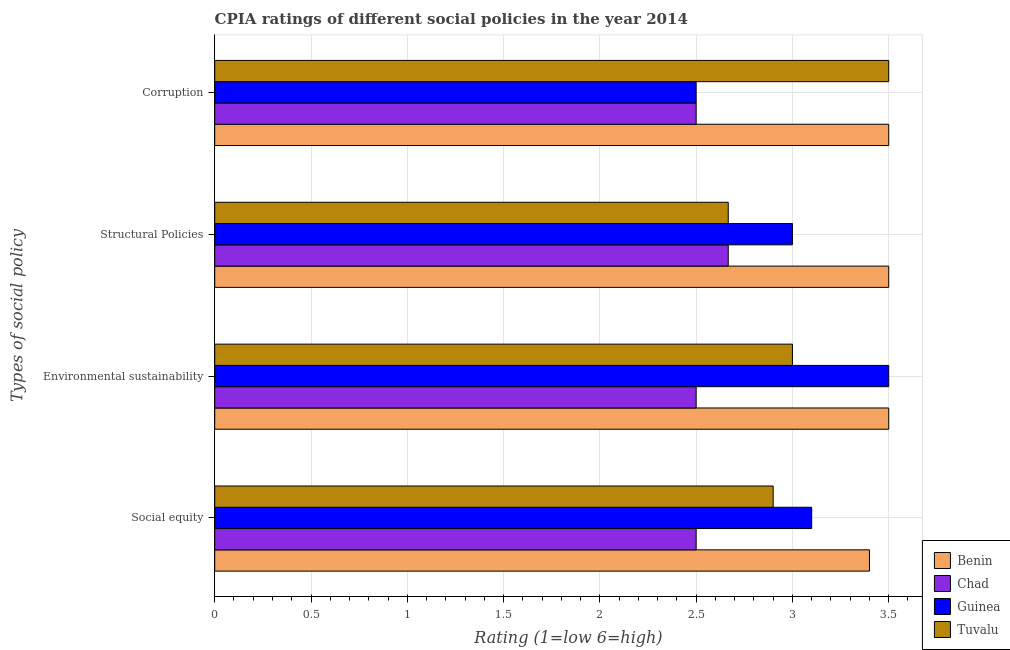How many groups of bars are there?
Give a very brief answer. 4. How many bars are there on the 1st tick from the bottom?
Offer a terse response. 4. What is the label of the 1st group of bars from the top?
Keep it short and to the point. Corruption. What is the cpia rating of structural policies in Tuvalu?
Your response must be concise. 2.67. Across all countries, what is the maximum cpia rating of social equity?
Offer a very short reply. 3.4. Across all countries, what is the minimum cpia rating of structural policies?
Make the answer very short. 2.67. In which country was the cpia rating of social equity maximum?
Your response must be concise. Benin. In which country was the cpia rating of environmental sustainability minimum?
Ensure brevity in your answer.  Chad. What is the total cpia rating of corruption in the graph?
Your answer should be very brief. 12. What is the difference between the cpia rating of structural policies in Tuvalu and that in Guinea?
Your answer should be very brief. -0.33. What is the difference between the cpia rating of corruption in Guinea and the cpia rating of social equity in Benin?
Provide a short and direct response. -0.9. What is the average cpia rating of environmental sustainability per country?
Your response must be concise. 3.12. What is the difference between the cpia rating of social equity and cpia rating of structural policies in Tuvalu?
Provide a short and direct response. 0.23. In how many countries, is the cpia rating of environmental sustainability greater than 2.4 ?
Give a very brief answer. 4. What is the ratio of the cpia rating of social equity in Tuvalu to that in Chad?
Your answer should be compact. 1.16. What is the difference between the highest and the lowest cpia rating of corruption?
Offer a very short reply. 1. Is the sum of the cpia rating of social equity in Benin and Guinea greater than the maximum cpia rating of structural policies across all countries?
Offer a very short reply. Yes. Is it the case that in every country, the sum of the cpia rating of corruption and cpia rating of environmental sustainability is greater than the sum of cpia rating of social equity and cpia rating of structural policies?
Offer a very short reply. No. What does the 4th bar from the top in Structural Policies represents?
Your answer should be very brief. Benin. What does the 3rd bar from the bottom in Environmental sustainability represents?
Give a very brief answer. Guinea. How many bars are there?
Offer a very short reply. 16. Are all the bars in the graph horizontal?
Give a very brief answer. Yes. How many countries are there in the graph?
Offer a very short reply. 4. What is the difference between two consecutive major ticks on the X-axis?
Your answer should be very brief. 0.5. Does the graph contain any zero values?
Ensure brevity in your answer.  No. What is the title of the graph?
Ensure brevity in your answer.  CPIA ratings of different social policies in the year 2014. Does "Afghanistan" appear as one of the legend labels in the graph?
Your response must be concise. No. What is the label or title of the Y-axis?
Provide a succinct answer. Types of social policy. What is the Rating (1=low 6=high) in Chad in Social equity?
Offer a very short reply. 2.5. What is the Rating (1=low 6=high) in Chad in Environmental sustainability?
Ensure brevity in your answer.  2.5. What is the Rating (1=low 6=high) in Benin in Structural Policies?
Your answer should be compact. 3.5. What is the Rating (1=low 6=high) of Chad in Structural Policies?
Make the answer very short. 2.67. What is the Rating (1=low 6=high) in Guinea in Structural Policies?
Offer a very short reply. 3. What is the Rating (1=low 6=high) of Tuvalu in Structural Policies?
Your answer should be compact. 2.67. What is the Rating (1=low 6=high) in Benin in Corruption?
Provide a short and direct response. 3.5. What is the Rating (1=low 6=high) in Chad in Corruption?
Offer a very short reply. 2.5. What is the Rating (1=low 6=high) of Tuvalu in Corruption?
Your response must be concise. 3.5. Across all Types of social policy, what is the maximum Rating (1=low 6=high) of Benin?
Make the answer very short. 3.5. Across all Types of social policy, what is the maximum Rating (1=low 6=high) in Chad?
Give a very brief answer. 2.67. Across all Types of social policy, what is the maximum Rating (1=low 6=high) in Tuvalu?
Offer a very short reply. 3.5. Across all Types of social policy, what is the minimum Rating (1=low 6=high) of Benin?
Offer a very short reply. 3.4. Across all Types of social policy, what is the minimum Rating (1=low 6=high) in Chad?
Ensure brevity in your answer.  2.5. Across all Types of social policy, what is the minimum Rating (1=low 6=high) in Guinea?
Offer a very short reply. 2.5. Across all Types of social policy, what is the minimum Rating (1=low 6=high) in Tuvalu?
Offer a very short reply. 2.67. What is the total Rating (1=low 6=high) in Chad in the graph?
Your answer should be very brief. 10.17. What is the total Rating (1=low 6=high) in Tuvalu in the graph?
Offer a very short reply. 12.07. What is the difference between the Rating (1=low 6=high) in Benin in Social equity and that in Environmental sustainability?
Your response must be concise. -0.1. What is the difference between the Rating (1=low 6=high) in Chad in Social equity and that in Environmental sustainability?
Give a very brief answer. 0. What is the difference between the Rating (1=low 6=high) of Guinea in Social equity and that in Environmental sustainability?
Provide a short and direct response. -0.4. What is the difference between the Rating (1=low 6=high) in Tuvalu in Social equity and that in Environmental sustainability?
Provide a short and direct response. -0.1. What is the difference between the Rating (1=low 6=high) of Guinea in Social equity and that in Structural Policies?
Offer a very short reply. 0.1. What is the difference between the Rating (1=low 6=high) of Tuvalu in Social equity and that in Structural Policies?
Provide a succinct answer. 0.23. What is the difference between the Rating (1=low 6=high) of Tuvalu in Social equity and that in Corruption?
Make the answer very short. -0.6. What is the difference between the Rating (1=low 6=high) in Tuvalu in Environmental sustainability and that in Structural Policies?
Keep it short and to the point. 0.33. What is the difference between the Rating (1=low 6=high) of Tuvalu in Environmental sustainability and that in Corruption?
Provide a short and direct response. -0.5. What is the difference between the Rating (1=low 6=high) in Benin in Structural Policies and that in Corruption?
Your answer should be compact. 0. What is the difference between the Rating (1=low 6=high) of Guinea in Structural Policies and that in Corruption?
Make the answer very short. 0.5. What is the difference between the Rating (1=low 6=high) of Benin in Social equity and the Rating (1=low 6=high) of Chad in Environmental sustainability?
Keep it short and to the point. 0.9. What is the difference between the Rating (1=low 6=high) of Chad in Social equity and the Rating (1=low 6=high) of Guinea in Environmental sustainability?
Make the answer very short. -1. What is the difference between the Rating (1=low 6=high) in Guinea in Social equity and the Rating (1=low 6=high) in Tuvalu in Environmental sustainability?
Offer a very short reply. 0.1. What is the difference between the Rating (1=low 6=high) of Benin in Social equity and the Rating (1=low 6=high) of Chad in Structural Policies?
Your response must be concise. 0.73. What is the difference between the Rating (1=low 6=high) in Benin in Social equity and the Rating (1=low 6=high) in Tuvalu in Structural Policies?
Provide a succinct answer. 0.73. What is the difference between the Rating (1=low 6=high) of Guinea in Social equity and the Rating (1=low 6=high) of Tuvalu in Structural Policies?
Your response must be concise. 0.43. What is the difference between the Rating (1=low 6=high) in Benin in Social equity and the Rating (1=low 6=high) in Guinea in Corruption?
Ensure brevity in your answer.  0.9. What is the difference between the Rating (1=low 6=high) of Chad in Social equity and the Rating (1=low 6=high) of Tuvalu in Corruption?
Provide a succinct answer. -1. What is the difference between the Rating (1=low 6=high) in Benin in Environmental sustainability and the Rating (1=low 6=high) in Guinea in Structural Policies?
Offer a very short reply. 0.5. What is the difference between the Rating (1=low 6=high) in Benin in Environmental sustainability and the Rating (1=low 6=high) in Tuvalu in Structural Policies?
Ensure brevity in your answer.  0.83. What is the difference between the Rating (1=low 6=high) in Chad in Environmental sustainability and the Rating (1=low 6=high) in Tuvalu in Structural Policies?
Your response must be concise. -0.17. What is the difference between the Rating (1=low 6=high) in Benin in Environmental sustainability and the Rating (1=low 6=high) in Guinea in Corruption?
Make the answer very short. 1. What is the difference between the Rating (1=low 6=high) of Benin in Environmental sustainability and the Rating (1=low 6=high) of Tuvalu in Corruption?
Give a very brief answer. 0. What is the difference between the Rating (1=low 6=high) of Chad in Environmental sustainability and the Rating (1=low 6=high) of Guinea in Corruption?
Make the answer very short. 0. What is the difference between the Rating (1=low 6=high) of Chad in Environmental sustainability and the Rating (1=low 6=high) of Tuvalu in Corruption?
Offer a very short reply. -1. What is the difference between the Rating (1=low 6=high) in Benin in Structural Policies and the Rating (1=low 6=high) in Guinea in Corruption?
Your answer should be very brief. 1. What is the difference between the Rating (1=low 6=high) in Chad in Structural Policies and the Rating (1=low 6=high) in Guinea in Corruption?
Offer a very short reply. 0.17. What is the difference between the Rating (1=low 6=high) of Chad in Structural Policies and the Rating (1=low 6=high) of Tuvalu in Corruption?
Make the answer very short. -0.83. What is the difference between the Rating (1=low 6=high) of Guinea in Structural Policies and the Rating (1=low 6=high) of Tuvalu in Corruption?
Keep it short and to the point. -0.5. What is the average Rating (1=low 6=high) of Benin per Types of social policy?
Provide a succinct answer. 3.48. What is the average Rating (1=low 6=high) of Chad per Types of social policy?
Make the answer very short. 2.54. What is the average Rating (1=low 6=high) of Guinea per Types of social policy?
Provide a succinct answer. 3.02. What is the average Rating (1=low 6=high) of Tuvalu per Types of social policy?
Your answer should be compact. 3.02. What is the difference between the Rating (1=low 6=high) of Benin and Rating (1=low 6=high) of Guinea in Social equity?
Ensure brevity in your answer.  0.3. What is the difference between the Rating (1=low 6=high) of Benin and Rating (1=low 6=high) of Tuvalu in Social equity?
Your answer should be compact. 0.5. What is the difference between the Rating (1=low 6=high) of Chad and Rating (1=low 6=high) of Guinea in Social equity?
Make the answer very short. -0.6. What is the difference between the Rating (1=low 6=high) of Chad and Rating (1=low 6=high) of Tuvalu in Social equity?
Keep it short and to the point. -0.4. What is the difference between the Rating (1=low 6=high) in Guinea and Rating (1=low 6=high) in Tuvalu in Social equity?
Offer a very short reply. 0.2. What is the difference between the Rating (1=low 6=high) of Chad and Rating (1=low 6=high) of Guinea in Environmental sustainability?
Your response must be concise. -1. What is the difference between the Rating (1=low 6=high) of Chad and Rating (1=low 6=high) of Tuvalu in Environmental sustainability?
Your response must be concise. -0.5. What is the difference between the Rating (1=low 6=high) of Guinea and Rating (1=low 6=high) of Tuvalu in Environmental sustainability?
Keep it short and to the point. 0.5. What is the difference between the Rating (1=low 6=high) in Benin and Rating (1=low 6=high) in Chad in Structural Policies?
Your response must be concise. 0.83. What is the difference between the Rating (1=low 6=high) in Benin and Rating (1=low 6=high) in Guinea in Structural Policies?
Offer a terse response. 0.5. What is the difference between the Rating (1=low 6=high) in Benin and Rating (1=low 6=high) in Tuvalu in Structural Policies?
Give a very brief answer. 0.83. What is the difference between the Rating (1=low 6=high) in Chad and Rating (1=low 6=high) in Tuvalu in Structural Policies?
Give a very brief answer. 0. What is the difference between the Rating (1=low 6=high) in Benin and Rating (1=low 6=high) in Chad in Corruption?
Give a very brief answer. 1. What is the difference between the Rating (1=low 6=high) in Benin and Rating (1=low 6=high) in Guinea in Corruption?
Offer a terse response. 1. What is the difference between the Rating (1=low 6=high) of Benin and Rating (1=low 6=high) of Tuvalu in Corruption?
Your answer should be very brief. 0. What is the difference between the Rating (1=low 6=high) in Chad and Rating (1=low 6=high) in Guinea in Corruption?
Provide a succinct answer. 0. What is the difference between the Rating (1=low 6=high) of Guinea and Rating (1=low 6=high) of Tuvalu in Corruption?
Your answer should be compact. -1. What is the ratio of the Rating (1=low 6=high) of Benin in Social equity to that in Environmental sustainability?
Your answer should be compact. 0.97. What is the ratio of the Rating (1=low 6=high) in Guinea in Social equity to that in Environmental sustainability?
Your answer should be compact. 0.89. What is the ratio of the Rating (1=low 6=high) in Tuvalu in Social equity to that in Environmental sustainability?
Your answer should be compact. 0.97. What is the ratio of the Rating (1=low 6=high) in Benin in Social equity to that in Structural Policies?
Offer a very short reply. 0.97. What is the ratio of the Rating (1=low 6=high) in Guinea in Social equity to that in Structural Policies?
Your answer should be compact. 1.03. What is the ratio of the Rating (1=low 6=high) in Tuvalu in Social equity to that in Structural Policies?
Provide a succinct answer. 1.09. What is the ratio of the Rating (1=low 6=high) of Benin in Social equity to that in Corruption?
Give a very brief answer. 0.97. What is the ratio of the Rating (1=low 6=high) in Chad in Social equity to that in Corruption?
Ensure brevity in your answer.  1. What is the ratio of the Rating (1=low 6=high) in Guinea in Social equity to that in Corruption?
Keep it short and to the point. 1.24. What is the ratio of the Rating (1=low 6=high) of Tuvalu in Social equity to that in Corruption?
Make the answer very short. 0.83. What is the ratio of the Rating (1=low 6=high) of Benin in Environmental sustainability to that in Structural Policies?
Make the answer very short. 1. What is the ratio of the Rating (1=low 6=high) of Chad in Environmental sustainability to that in Structural Policies?
Provide a succinct answer. 0.94. What is the ratio of the Rating (1=low 6=high) in Guinea in Environmental sustainability to that in Structural Policies?
Your answer should be compact. 1.17. What is the ratio of the Rating (1=low 6=high) in Tuvalu in Environmental sustainability to that in Structural Policies?
Ensure brevity in your answer.  1.12. What is the ratio of the Rating (1=low 6=high) in Benin in Environmental sustainability to that in Corruption?
Ensure brevity in your answer.  1. What is the ratio of the Rating (1=low 6=high) of Guinea in Environmental sustainability to that in Corruption?
Offer a terse response. 1.4. What is the ratio of the Rating (1=low 6=high) of Tuvalu in Environmental sustainability to that in Corruption?
Your response must be concise. 0.86. What is the ratio of the Rating (1=low 6=high) of Chad in Structural Policies to that in Corruption?
Your answer should be compact. 1.07. What is the ratio of the Rating (1=low 6=high) of Tuvalu in Structural Policies to that in Corruption?
Ensure brevity in your answer.  0.76. What is the difference between the highest and the second highest Rating (1=low 6=high) of Tuvalu?
Offer a terse response. 0.5. What is the difference between the highest and the lowest Rating (1=low 6=high) in Tuvalu?
Provide a succinct answer. 0.83. 